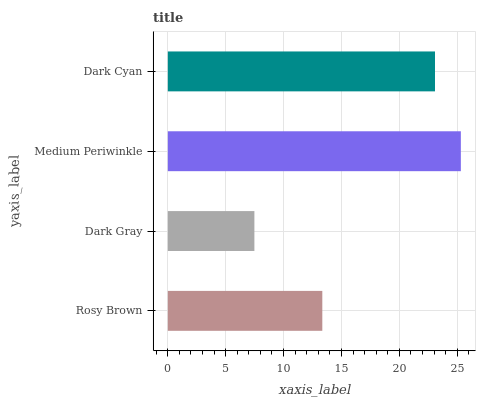Is Dark Gray the minimum?
Answer yes or no. Yes. Is Medium Periwinkle the maximum?
Answer yes or no. Yes. Is Medium Periwinkle the minimum?
Answer yes or no. No. Is Dark Gray the maximum?
Answer yes or no. No. Is Medium Periwinkle greater than Dark Gray?
Answer yes or no. Yes. Is Dark Gray less than Medium Periwinkle?
Answer yes or no. Yes. Is Dark Gray greater than Medium Periwinkle?
Answer yes or no. No. Is Medium Periwinkle less than Dark Gray?
Answer yes or no. No. Is Dark Cyan the high median?
Answer yes or no. Yes. Is Rosy Brown the low median?
Answer yes or no. Yes. Is Rosy Brown the high median?
Answer yes or no. No. Is Medium Periwinkle the low median?
Answer yes or no. No. 